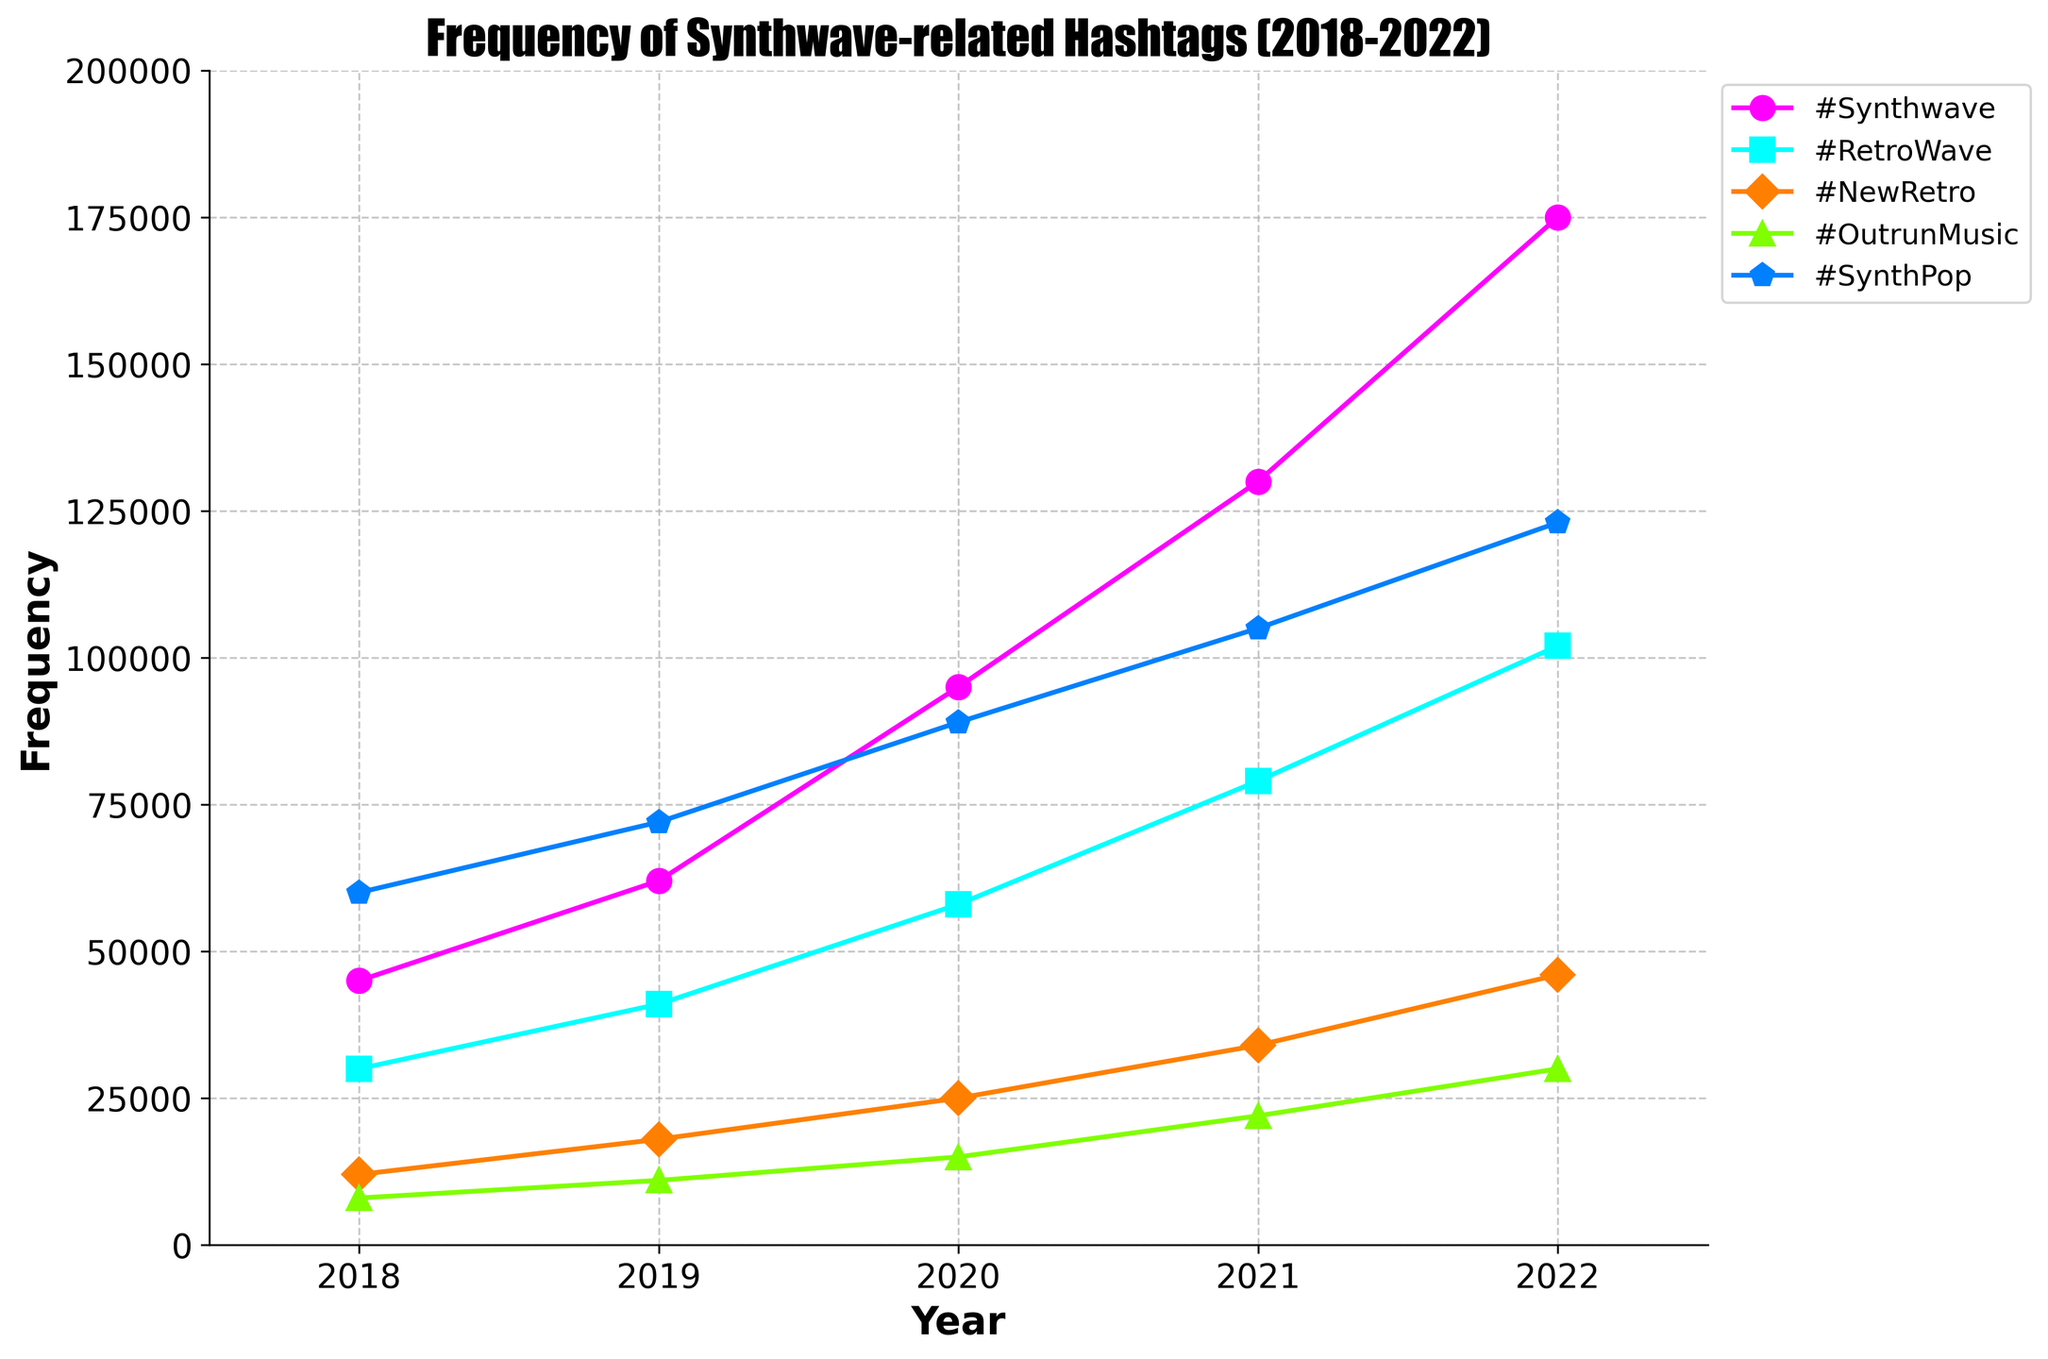Which hashtag had the highest frequency in 2022? To determine this, look at the values for each hashtag in 2022. The highest value is for #Synthwave at 175,000.
Answer: #Synthwave What was the total frequency of #SynthPop over the 5 years? Sum the frequency values for #SynthPop from 2018 to 2022: 60,000 + 72,000 + 89,000 + 105,000 + 123,000. The sum is 449,000.
Answer: 449,000 Which hashtag showed the largest increase in frequency from 2018 to 2022? Compute the difference in frequency between 2022 and 2018 for each hashtag. The differences are:
- #Synthwave: 175,000 - 45,000 = 130,000
- #RetroWave: 102,000 - 30,000 = 72,000
- #NewRetro: 46,000 - 12,000 = 34,000
- #OutrunMusic: 30,000 - 8,000 = 22,000
- #SynthPop: 123,000 - 60,000 = 63,000
The largest increase is for #Synthwave at 130,000.
Answer: #Synthwave In which year did #NewRetro have more frequency than #OutrunMusic? Compare the yearly values for #NewRetro and #OutrunMusic. In 2020, 25,000 (#NewRetro) > 15,000 (#OutrunMusic), in 2021, 34,000 (#NewRetro) > 22,000 (#OutrunMusic), and in 2022, 46,000 (#NewRetro) > 30,000 (#OutrunMusic).
Answer: 2020, 2021, 2022 Which hashtag had the lowest frequency in 2019? Compare the frequency values for each hashtag in 2019. The lowest value is for #OutrunMusic at 11,000.
Answer: #OutrunMusic What is the average frequency of #RetroWave over the 5 years? Sum the frequencies for #RetroWave from 2018-2022: 30,000 + 41,000 + 58,000 + 79,000 + 102,000 = 310,000. Divide by the number of years (5): 310,000 / 5 = 62,000.
Answer: 62,000 How did the frequency of #Synthwave change from 2020 to 2021? Subtract the frequency of #Synthwave in 2020 from its frequency in 2021: 130,000 - 95,000 = 35,000. There was an increase of 35,000.
Answer: Increase by 35,000 Which year showed the steepest increase in frequency for #Synthwave? Analyze the yearly changes for #Synthwave:
- 2018 to 2019: 62,000 - 45,000 = 17,000
- 2019 to 2020: 95,000 - 62,000 = 33,000
- 2020 to 2021: 130,000 - 95,000 = 35,000
- 2021 to 2022: 175,000 - 130,000 = 45,000
The steepest increase was from 2021 to 2022 with an increase of 45,000.
Answer: 2021 to 2022 What is the overall trend of #OutrunMusic from 2018 to 2022? Observe the frequency values for #OutrunMusic across the years: 8,000, 11,000, 15,000, 22,000, 30,000. The frequency increases steadily each year.
Answer: Increasing steadily Compare the frequency of #SynthPop in 2020 and #RetroWave in 2021. Which was higher? Check the values for #SynthPop in 2020 (89,000) and #RetroWave in 2021 (79,000). #SynthPop had a higher frequency in 2020.
Answer: #SynthPop in 2020 